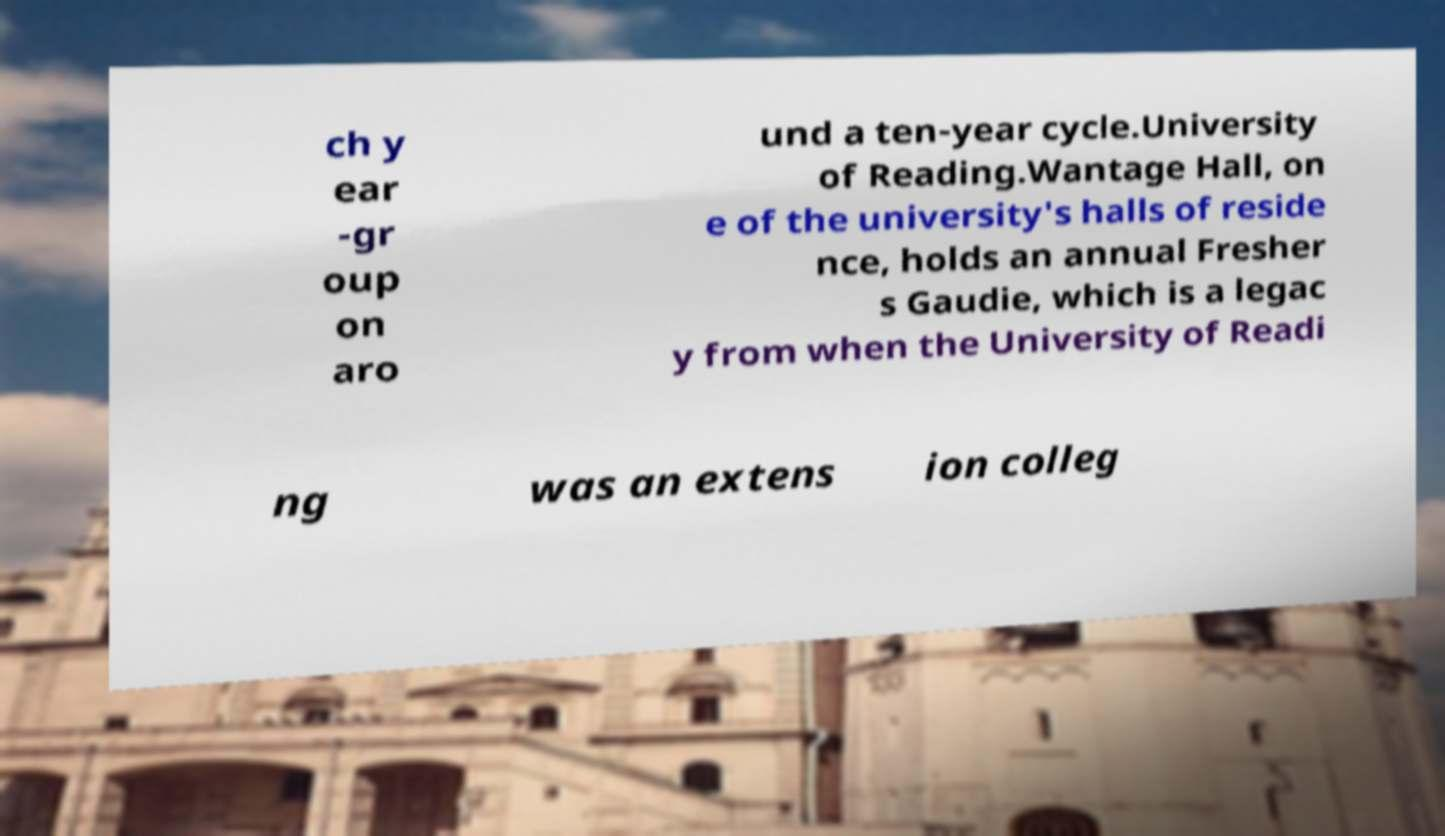I need the written content from this picture converted into text. Can you do that? ch y ear -gr oup on aro und a ten-year cycle.University of Reading.Wantage Hall, on e of the university's halls of reside nce, holds an annual Fresher s Gaudie, which is a legac y from when the University of Readi ng was an extens ion colleg 